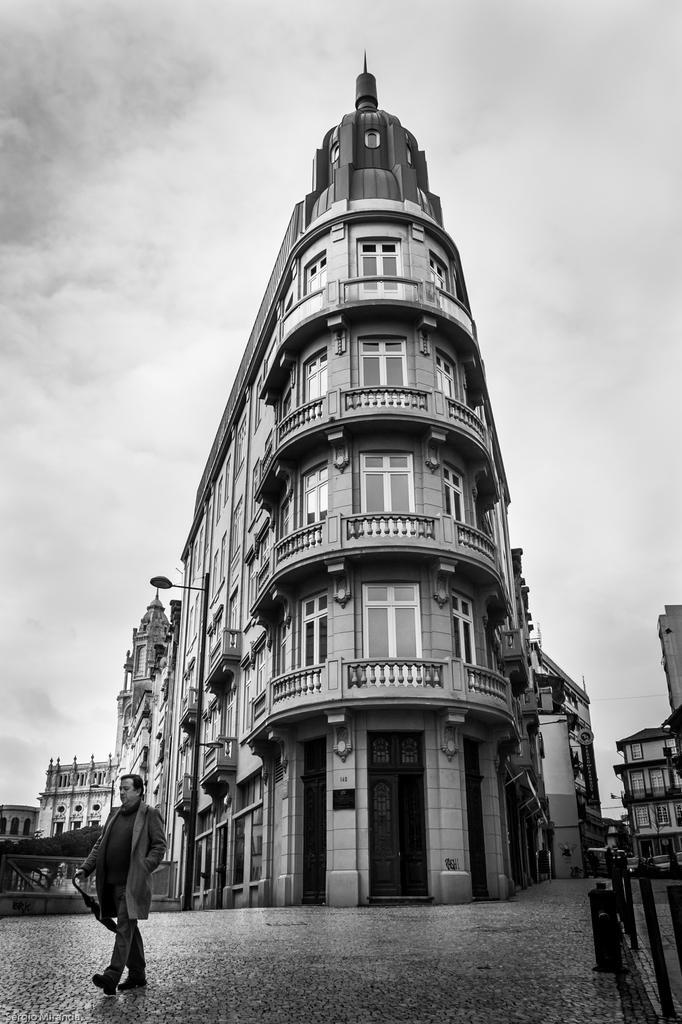Can you describe this image briefly? In this image we can see a black and white picture of few buildings, a person walking in front of the building, a light to the building, rods on the wall and sky in the background. 